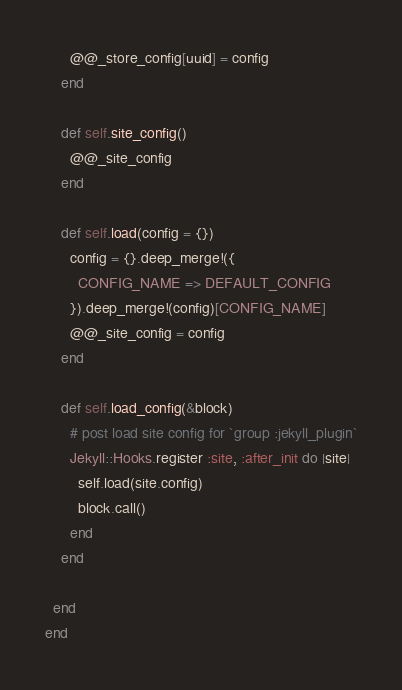<code> <loc_0><loc_0><loc_500><loc_500><_Ruby_>      @@_store_config[uuid] = config
    end

    def self.site_config()
      @@_site_config
    end

    def self.load(config = {})
      config = {}.deep_merge!({
        CONFIG_NAME => DEFAULT_CONFIG
      }).deep_merge!(config)[CONFIG_NAME]
      @@_site_config = config
    end

    def self.load_config(&block)
      # post load site config for `group :jekyll_plugin`
      Jekyll::Hooks.register :site, :after_init do |site|
        self.load(site.config)
        block.call()
      end
    end

  end
end
</code> 